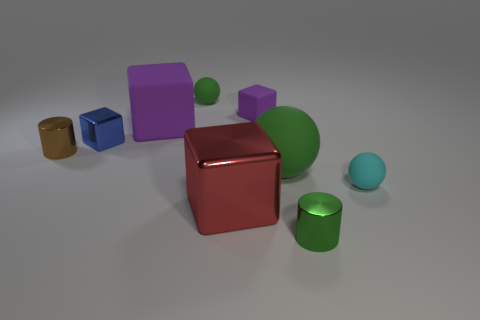What can you tell me about the lighting in this scene? The lighting in this scene is soft and diffused, coming from a direction above the arrangement of shapes, casting gentle shadows on the ground. It highlights the contours and textures of the objects without creating harsh glare, suggesting a calm and neutral ambiance. 